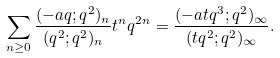<formula> <loc_0><loc_0><loc_500><loc_500>\sum _ { n \geq 0 } \frac { ( - a q ; q ^ { 2 } ) _ { n } } { ( q ^ { 2 } ; q ^ { 2 } ) _ { n } } t ^ { n } q ^ { 2 n } = \frac { ( - a t q ^ { 3 } ; q ^ { 2 } ) _ { \infty } } { ( t q ^ { 2 } ; q ^ { 2 } ) _ { \infty } } .</formula> 